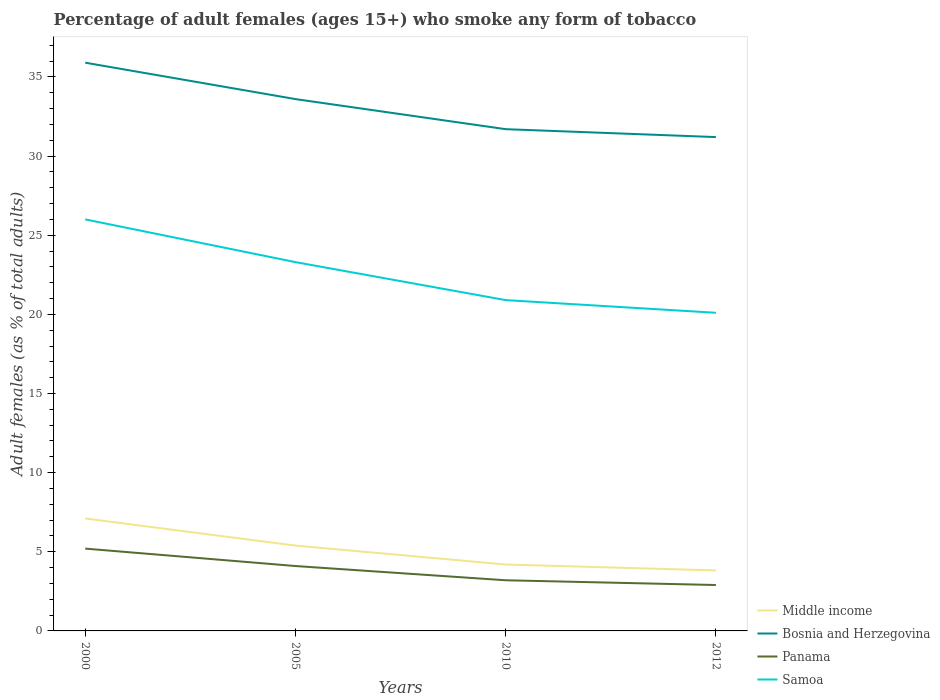Does the line corresponding to Middle income intersect with the line corresponding to Bosnia and Herzegovina?
Offer a terse response. No. Is the number of lines equal to the number of legend labels?
Offer a very short reply. Yes. Across all years, what is the maximum percentage of adult females who smoke in Samoa?
Ensure brevity in your answer.  20.1. What is the total percentage of adult females who smoke in Bosnia and Herzegovina in the graph?
Your response must be concise. 4.2. What is the difference between the highest and the second highest percentage of adult females who smoke in Panama?
Your answer should be compact. 2.3. What is the difference between the highest and the lowest percentage of adult females who smoke in Bosnia and Herzegovina?
Your answer should be compact. 2. Is the percentage of adult females who smoke in Middle income strictly greater than the percentage of adult females who smoke in Samoa over the years?
Your response must be concise. Yes. How many years are there in the graph?
Offer a terse response. 4. What is the difference between two consecutive major ticks on the Y-axis?
Provide a succinct answer. 5. Are the values on the major ticks of Y-axis written in scientific E-notation?
Keep it short and to the point. No. Does the graph contain any zero values?
Your answer should be very brief. No. How many legend labels are there?
Your answer should be very brief. 4. What is the title of the graph?
Offer a terse response. Percentage of adult females (ages 15+) who smoke any form of tobacco. What is the label or title of the X-axis?
Provide a succinct answer. Years. What is the label or title of the Y-axis?
Offer a terse response. Adult females (as % of total adults). What is the Adult females (as % of total adults) in Middle income in 2000?
Offer a very short reply. 7.1. What is the Adult females (as % of total adults) of Bosnia and Herzegovina in 2000?
Make the answer very short. 35.9. What is the Adult females (as % of total adults) of Middle income in 2005?
Ensure brevity in your answer.  5.39. What is the Adult females (as % of total adults) of Bosnia and Herzegovina in 2005?
Give a very brief answer. 33.6. What is the Adult females (as % of total adults) in Panama in 2005?
Give a very brief answer. 4.1. What is the Adult females (as % of total adults) in Samoa in 2005?
Provide a short and direct response. 23.3. What is the Adult females (as % of total adults) in Middle income in 2010?
Make the answer very short. 4.2. What is the Adult females (as % of total adults) of Bosnia and Herzegovina in 2010?
Keep it short and to the point. 31.7. What is the Adult females (as % of total adults) in Samoa in 2010?
Offer a terse response. 20.9. What is the Adult females (as % of total adults) of Middle income in 2012?
Make the answer very short. 3.82. What is the Adult females (as % of total adults) of Bosnia and Herzegovina in 2012?
Provide a succinct answer. 31.2. What is the Adult females (as % of total adults) of Samoa in 2012?
Ensure brevity in your answer.  20.1. Across all years, what is the maximum Adult females (as % of total adults) of Middle income?
Give a very brief answer. 7.1. Across all years, what is the maximum Adult females (as % of total adults) in Bosnia and Herzegovina?
Offer a very short reply. 35.9. Across all years, what is the minimum Adult females (as % of total adults) in Middle income?
Ensure brevity in your answer.  3.82. Across all years, what is the minimum Adult females (as % of total adults) in Bosnia and Herzegovina?
Your response must be concise. 31.2. Across all years, what is the minimum Adult females (as % of total adults) in Panama?
Offer a very short reply. 2.9. Across all years, what is the minimum Adult females (as % of total adults) in Samoa?
Your response must be concise. 20.1. What is the total Adult females (as % of total adults) of Middle income in the graph?
Ensure brevity in your answer.  20.51. What is the total Adult females (as % of total adults) of Bosnia and Herzegovina in the graph?
Provide a succinct answer. 132.4. What is the total Adult females (as % of total adults) in Samoa in the graph?
Give a very brief answer. 90.3. What is the difference between the Adult females (as % of total adults) of Middle income in 2000 and that in 2005?
Your response must be concise. 1.71. What is the difference between the Adult females (as % of total adults) of Samoa in 2000 and that in 2005?
Provide a succinct answer. 2.7. What is the difference between the Adult females (as % of total adults) of Middle income in 2000 and that in 2010?
Ensure brevity in your answer.  2.91. What is the difference between the Adult females (as % of total adults) in Middle income in 2000 and that in 2012?
Your answer should be compact. 3.28. What is the difference between the Adult females (as % of total adults) of Bosnia and Herzegovina in 2000 and that in 2012?
Give a very brief answer. 4.7. What is the difference between the Adult females (as % of total adults) in Samoa in 2000 and that in 2012?
Make the answer very short. 5.9. What is the difference between the Adult females (as % of total adults) in Middle income in 2005 and that in 2010?
Provide a short and direct response. 1.19. What is the difference between the Adult females (as % of total adults) in Samoa in 2005 and that in 2010?
Offer a terse response. 2.4. What is the difference between the Adult females (as % of total adults) in Middle income in 2005 and that in 2012?
Your response must be concise. 1.57. What is the difference between the Adult females (as % of total adults) in Panama in 2005 and that in 2012?
Your answer should be compact. 1.2. What is the difference between the Adult females (as % of total adults) in Samoa in 2005 and that in 2012?
Make the answer very short. 3.2. What is the difference between the Adult females (as % of total adults) in Middle income in 2010 and that in 2012?
Give a very brief answer. 0.37. What is the difference between the Adult females (as % of total adults) in Bosnia and Herzegovina in 2010 and that in 2012?
Keep it short and to the point. 0.5. What is the difference between the Adult females (as % of total adults) of Panama in 2010 and that in 2012?
Offer a very short reply. 0.3. What is the difference between the Adult females (as % of total adults) in Samoa in 2010 and that in 2012?
Make the answer very short. 0.8. What is the difference between the Adult females (as % of total adults) in Middle income in 2000 and the Adult females (as % of total adults) in Bosnia and Herzegovina in 2005?
Give a very brief answer. -26.5. What is the difference between the Adult females (as % of total adults) of Middle income in 2000 and the Adult females (as % of total adults) of Panama in 2005?
Provide a succinct answer. 3. What is the difference between the Adult females (as % of total adults) in Middle income in 2000 and the Adult females (as % of total adults) in Samoa in 2005?
Your answer should be very brief. -16.2. What is the difference between the Adult females (as % of total adults) in Bosnia and Herzegovina in 2000 and the Adult females (as % of total adults) in Panama in 2005?
Your answer should be compact. 31.8. What is the difference between the Adult females (as % of total adults) in Bosnia and Herzegovina in 2000 and the Adult females (as % of total adults) in Samoa in 2005?
Your response must be concise. 12.6. What is the difference between the Adult females (as % of total adults) in Panama in 2000 and the Adult females (as % of total adults) in Samoa in 2005?
Keep it short and to the point. -18.1. What is the difference between the Adult females (as % of total adults) of Middle income in 2000 and the Adult females (as % of total adults) of Bosnia and Herzegovina in 2010?
Give a very brief answer. -24.6. What is the difference between the Adult females (as % of total adults) of Middle income in 2000 and the Adult females (as % of total adults) of Panama in 2010?
Your answer should be compact. 3.9. What is the difference between the Adult females (as % of total adults) in Middle income in 2000 and the Adult females (as % of total adults) in Samoa in 2010?
Your response must be concise. -13.8. What is the difference between the Adult females (as % of total adults) of Bosnia and Herzegovina in 2000 and the Adult females (as % of total adults) of Panama in 2010?
Offer a very short reply. 32.7. What is the difference between the Adult females (as % of total adults) of Bosnia and Herzegovina in 2000 and the Adult females (as % of total adults) of Samoa in 2010?
Your response must be concise. 15. What is the difference between the Adult females (as % of total adults) of Panama in 2000 and the Adult females (as % of total adults) of Samoa in 2010?
Make the answer very short. -15.7. What is the difference between the Adult females (as % of total adults) in Middle income in 2000 and the Adult females (as % of total adults) in Bosnia and Herzegovina in 2012?
Offer a very short reply. -24.1. What is the difference between the Adult females (as % of total adults) in Middle income in 2000 and the Adult females (as % of total adults) in Panama in 2012?
Provide a succinct answer. 4.2. What is the difference between the Adult females (as % of total adults) of Middle income in 2000 and the Adult females (as % of total adults) of Samoa in 2012?
Make the answer very short. -13. What is the difference between the Adult females (as % of total adults) in Bosnia and Herzegovina in 2000 and the Adult females (as % of total adults) in Samoa in 2012?
Give a very brief answer. 15.8. What is the difference between the Adult females (as % of total adults) of Panama in 2000 and the Adult females (as % of total adults) of Samoa in 2012?
Your answer should be compact. -14.9. What is the difference between the Adult females (as % of total adults) of Middle income in 2005 and the Adult females (as % of total adults) of Bosnia and Herzegovina in 2010?
Make the answer very short. -26.31. What is the difference between the Adult females (as % of total adults) of Middle income in 2005 and the Adult females (as % of total adults) of Panama in 2010?
Offer a terse response. 2.19. What is the difference between the Adult females (as % of total adults) in Middle income in 2005 and the Adult females (as % of total adults) in Samoa in 2010?
Provide a succinct answer. -15.51. What is the difference between the Adult females (as % of total adults) in Bosnia and Herzegovina in 2005 and the Adult females (as % of total adults) in Panama in 2010?
Give a very brief answer. 30.4. What is the difference between the Adult females (as % of total adults) of Bosnia and Herzegovina in 2005 and the Adult females (as % of total adults) of Samoa in 2010?
Keep it short and to the point. 12.7. What is the difference between the Adult females (as % of total adults) of Panama in 2005 and the Adult females (as % of total adults) of Samoa in 2010?
Your response must be concise. -16.8. What is the difference between the Adult females (as % of total adults) in Middle income in 2005 and the Adult females (as % of total adults) in Bosnia and Herzegovina in 2012?
Your answer should be very brief. -25.81. What is the difference between the Adult females (as % of total adults) of Middle income in 2005 and the Adult females (as % of total adults) of Panama in 2012?
Your response must be concise. 2.49. What is the difference between the Adult females (as % of total adults) of Middle income in 2005 and the Adult females (as % of total adults) of Samoa in 2012?
Keep it short and to the point. -14.71. What is the difference between the Adult females (as % of total adults) of Bosnia and Herzegovina in 2005 and the Adult females (as % of total adults) of Panama in 2012?
Keep it short and to the point. 30.7. What is the difference between the Adult females (as % of total adults) of Panama in 2005 and the Adult females (as % of total adults) of Samoa in 2012?
Ensure brevity in your answer.  -16. What is the difference between the Adult females (as % of total adults) of Middle income in 2010 and the Adult females (as % of total adults) of Bosnia and Herzegovina in 2012?
Make the answer very short. -27. What is the difference between the Adult females (as % of total adults) in Middle income in 2010 and the Adult females (as % of total adults) in Panama in 2012?
Your answer should be compact. 1.3. What is the difference between the Adult females (as % of total adults) of Middle income in 2010 and the Adult females (as % of total adults) of Samoa in 2012?
Provide a short and direct response. -15.9. What is the difference between the Adult females (as % of total adults) in Bosnia and Herzegovina in 2010 and the Adult females (as % of total adults) in Panama in 2012?
Your answer should be compact. 28.8. What is the difference between the Adult females (as % of total adults) in Panama in 2010 and the Adult females (as % of total adults) in Samoa in 2012?
Your answer should be compact. -16.9. What is the average Adult females (as % of total adults) of Middle income per year?
Give a very brief answer. 5.13. What is the average Adult females (as % of total adults) of Bosnia and Herzegovina per year?
Offer a terse response. 33.1. What is the average Adult females (as % of total adults) in Panama per year?
Your answer should be compact. 3.85. What is the average Adult females (as % of total adults) of Samoa per year?
Keep it short and to the point. 22.57. In the year 2000, what is the difference between the Adult females (as % of total adults) in Middle income and Adult females (as % of total adults) in Bosnia and Herzegovina?
Provide a short and direct response. -28.8. In the year 2000, what is the difference between the Adult females (as % of total adults) of Middle income and Adult females (as % of total adults) of Panama?
Keep it short and to the point. 1.9. In the year 2000, what is the difference between the Adult females (as % of total adults) in Middle income and Adult females (as % of total adults) in Samoa?
Provide a short and direct response. -18.9. In the year 2000, what is the difference between the Adult females (as % of total adults) in Bosnia and Herzegovina and Adult females (as % of total adults) in Panama?
Make the answer very short. 30.7. In the year 2000, what is the difference between the Adult females (as % of total adults) of Panama and Adult females (as % of total adults) of Samoa?
Provide a short and direct response. -20.8. In the year 2005, what is the difference between the Adult females (as % of total adults) of Middle income and Adult females (as % of total adults) of Bosnia and Herzegovina?
Keep it short and to the point. -28.21. In the year 2005, what is the difference between the Adult females (as % of total adults) of Middle income and Adult females (as % of total adults) of Panama?
Your answer should be very brief. 1.29. In the year 2005, what is the difference between the Adult females (as % of total adults) in Middle income and Adult females (as % of total adults) in Samoa?
Make the answer very short. -17.91. In the year 2005, what is the difference between the Adult females (as % of total adults) of Bosnia and Herzegovina and Adult females (as % of total adults) of Panama?
Provide a succinct answer. 29.5. In the year 2005, what is the difference between the Adult females (as % of total adults) of Bosnia and Herzegovina and Adult females (as % of total adults) of Samoa?
Make the answer very short. 10.3. In the year 2005, what is the difference between the Adult females (as % of total adults) of Panama and Adult females (as % of total adults) of Samoa?
Your answer should be very brief. -19.2. In the year 2010, what is the difference between the Adult females (as % of total adults) of Middle income and Adult females (as % of total adults) of Bosnia and Herzegovina?
Offer a terse response. -27.5. In the year 2010, what is the difference between the Adult females (as % of total adults) in Middle income and Adult females (as % of total adults) in Samoa?
Make the answer very short. -16.7. In the year 2010, what is the difference between the Adult females (as % of total adults) of Panama and Adult females (as % of total adults) of Samoa?
Provide a short and direct response. -17.7. In the year 2012, what is the difference between the Adult females (as % of total adults) in Middle income and Adult females (as % of total adults) in Bosnia and Herzegovina?
Provide a succinct answer. -27.38. In the year 2012, what is the difference between the Adult females (as % of total adults) of Middle income and Adult females (as % of total adults) of Panama?
Ensure brevity in your answer.  0.92. In the year 2012, what is the difference between the Adult females (as % of total adults) of Middle income and Adult females (as % of total adults) of Samoa?
Keep it short and to the point. -16.28. In the year 2012, what is the difference between the Adult females (as % of total adults) in Bosnia and Herzegovina and Adult females (as % of total adults) in Panama?
Ensure brevity in your answer.  28.3. In the year 2012, what is the difference between the Adult females (as % of total adults) of Panama and Adult females (as % of total adults) of Samoa?
Provide a short and direct response. -17.2. What is the ratio of the Adult females (as % of total adults) of Middle income in 2000 to that in 2005?
Your response must be concise. 1.32. What is the ratio of the Adult females (as % of total adults) of Bosnia and Herzegovina in 2000 to that in 2005?
Give a very brief answer. 1.07. What is the ratio of the Adult females (as % of total adults) of Panama in 2000 to that in 2005?
Provide a succinct answer. 1.27. What is the ratio of the Adult females (as % of total adults) of Samoa in 2000 to that in 2005?
Keep it short and to the point. 1.12. What is the ratio of the Adult females (as % of total adults) in Middle income in 2000 to that in 2010?
Ensure brevity in your answer.  1.69. What is the ratio of the Adult females (as % of total adults) of Bosnia and Herzegovina in 2000 to that in 2010?
Give a very brief answer. 1.13. What is the ratio of the Adult females (as % of total adults) of Panama in 2000 to that in 2010?
Your response must be concise. 1.62. What is the ratio of the Adult females (as % of total adults) in Samoa in 2000 to that in 2010?
Your response must be concise. 1.24. What is the ratio of the Adult females (as % of total adults) in Middle income in 2000 to that in 2012?
Make the answer very short. 1.86. What is the ratio of the Adult females (as % of total adults) of Bosnia and Herzegovina in 2000 to that in 2012?
Ensure brevity in your answer.  1.15. What is the ratio of the Adult females (as % of total adults) in Panama in 2000 to that in 2012?
Your answer should be compact. 1.79. What is the ratio of the Adult females (as % of total adults) of Samoa in 2000 to that in 2012?
Provide a short and direct response. 1.29. What is the ratio of the Adult females (as % of total adults) of Middle income in 2005 to that in 2010?
Provide a short and direct response. 1.28. What is the ratio of the Adult females (as % of total adults) in Bosnia and Herzegovina in 2005 to that in 2010?
Your answer should be compact. 1.06. What is the ratio of the Adult females (as % of total adults) in Panama in 2005 to that in 2010?
Provide a succinct answer. 1.28. What is the ratio of the Adult females (as % of total adults) of Samoa in 2005 to that in 2010?
Ensure brevity in your answer.  1.11. What is the ratio of the Adult females (as % of total adults) in Middle income in 2005 to that in 2012?
Your answer should be very brief. 1.41. What is the ratio of the Adult females (as % of total adults) of Panama in 2005 to that in 2012?
Your answer should be compact. 1.41. What is the ratio of the Adult females (as % of total adults) of Samoa in 2005 to that in 2012?
Give a very brief answer. 1.16. What is the ratio of the Adult females (as % of total adults) in Middle income in 2010 to that in 2012?
Provide a succinct answer. 1.1. What is the ratio of the Adult females (as % of total adults) in Panama in 2010 to that in 2012?
Keep it short and to the point. 1.1. What is the ratio of the Adult females (as % of total adults) of Samoa in 2010 to that in 2012?
Give a very brief answer. 1.04. What is the difference between the highest and the second highest Adult females (as % of total adults) of Middle income?
Give a very brief answer. 1.71. What is the difference between the highest and the second highest Adult females (as % of total adults) of Bosnia and Herzegovina?
Make the answer very short. 2.3. What is the difference between the highest and the second highest Adult females (as % of total adults) in Samoa?
Your answer should be very brief. 2.7. What is the difference between the highest and the lowest Adult females (as % of total adults) of Middle income?
Make the answer very short. 3.28. 